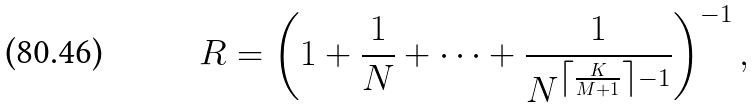<formula> <loc_0><loc_0><loc_500><loc_500>R = \left ( 1 + \frac { 1 } { N } + \dots + \frac { 1 } { N ^ { \left \lceil \frac { K } { M + 1 } \right \rceil - 1 } } \right ) ^ { - 1 } ,</formula> 